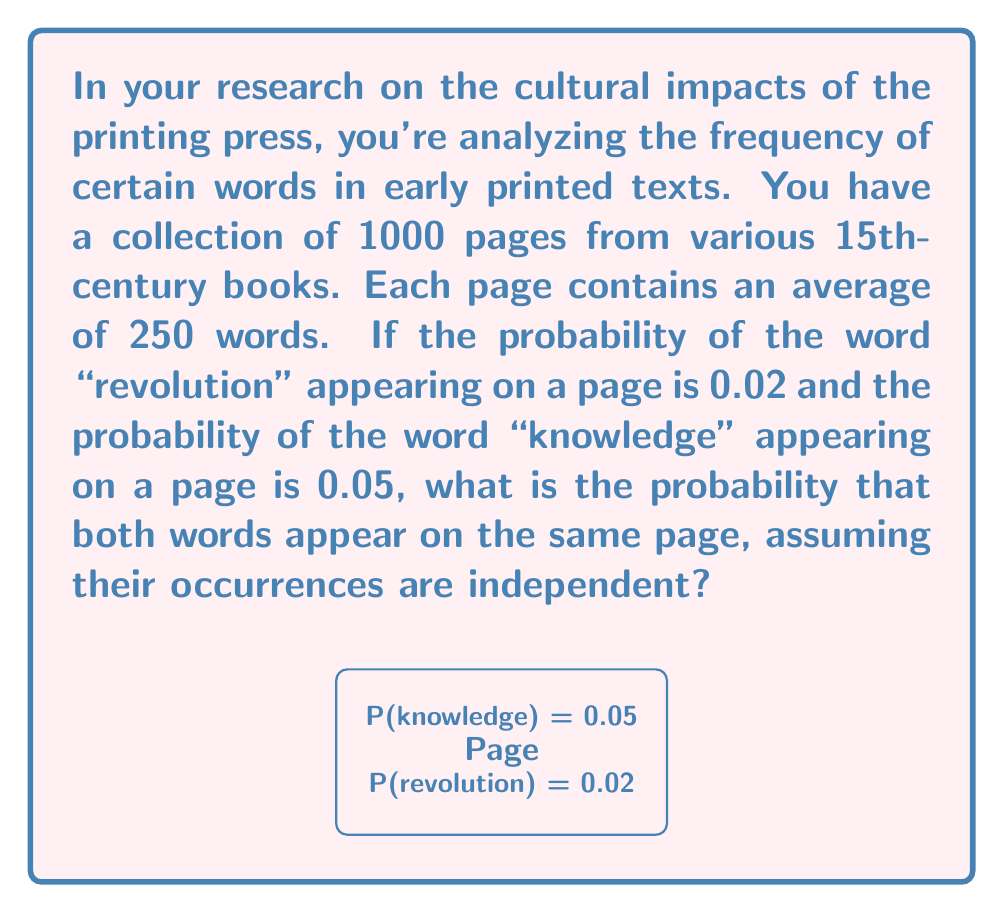Can you answer this question? Let's approach this step-by-step:

1) We're dealing with the probability of two independent events occurring together. In this case, we need to find:

   $P(\text{revolution and knowledge on same page})$

2) When events are independent, the probability of both occurring is the product of their individual probabilities:

   $P(A \text{ and } B) = P(A) \times P(B)$

3) We're given:
   $P(\text{revolution}) = 0.02$
   $P(\text{knowledge}) = 0.05$

4) Therefore:

   $P(\text{revolution and knowledge}) = 0.02 \times 0.05$

5) Let's calculate:

   $0.02 \times 0.05 = 0.001$

6) This means there's a 0.1% chance of both words appearing on the same page.

7) To verify: If we had 1000 pages, we'd expect to see both words together on approximately 1 page (0.001 × 1000 = 1).

This probability gives you an idea of how often these two concepts might have been discussed together in early printed texts, which could be an interesting point in your analysis of the printing press's cultural impact.
Answer: 0.001 or 0.1% 